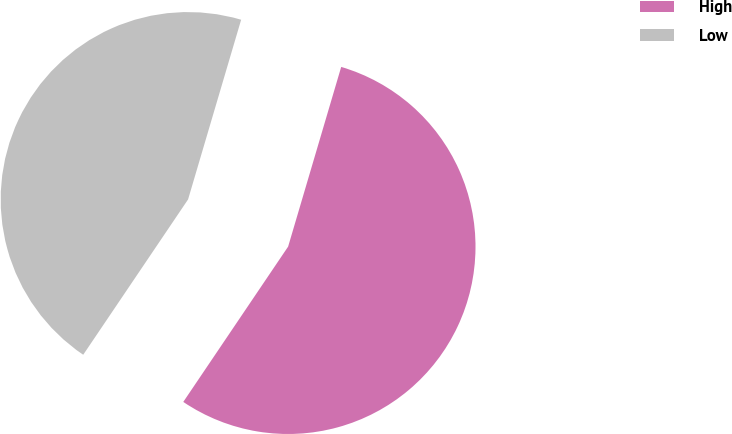<chart> <loc_0><loc_0><loc_500><loc_500><pie_chart><fcel>High<fcel>Low<nl><fcel>54.88%<fcel>45.12%<nl></chart> 